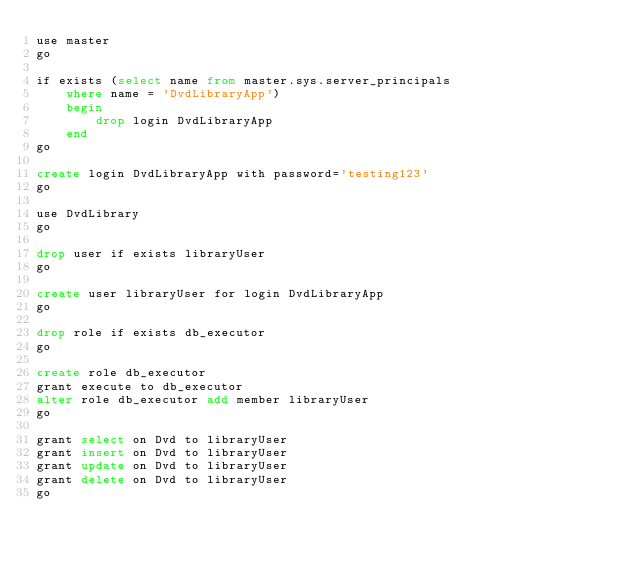<code> <loc_0><loc_0><loc_500><loc_500><_SQL_>use master
go

if exists (select name from master.sys.server_principals
	where name = 'DvdLibraryApp')
	begin
		drop login DvdLibraryApp
	end
go

create login DvdLibraryApp with password='testing123'
go

use DvdLibrary
go

drop user if exists libraryUser
go

create user libraryUser for login DvdLibraryApp
go

drop role if exists db_executor
go

create role db_executor
grant execute to db_executor
alter role db_executor add member libraryUser
go

grant select on Dvd to libraryUser
grant insert on Dvd to libraryUser
grant update on Dvd to libraryUser
grant delete on Dvd to libraryUser
go</code> 